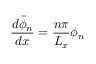Convert formula to latex. <formula><loc_0><loc_0><loc_500><loc_500>\frac { d \bar { \phi } _ { n } } { d x } = \frac { n \pi } { L _ { x } } \phi _ { n }</formula> 